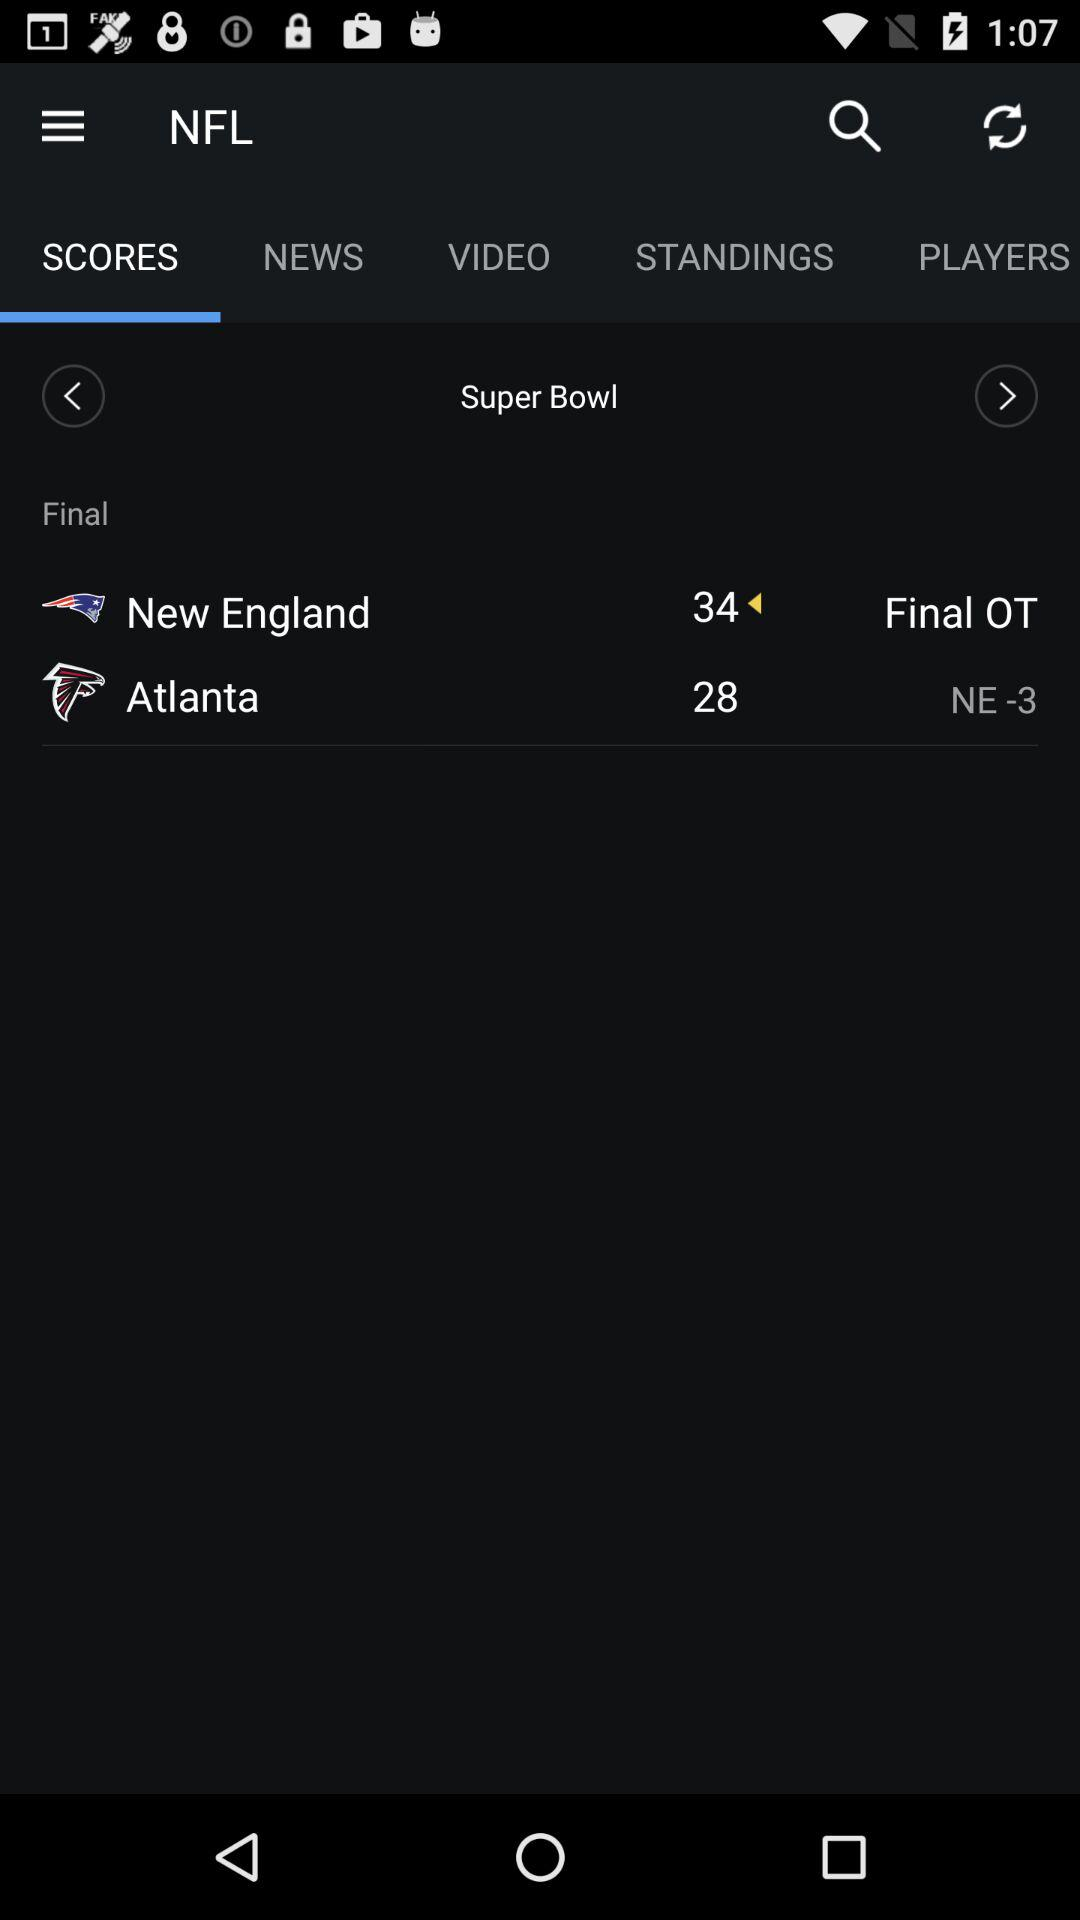What is the score of "Atlanta"? The score of "Atlanta" is 28. 